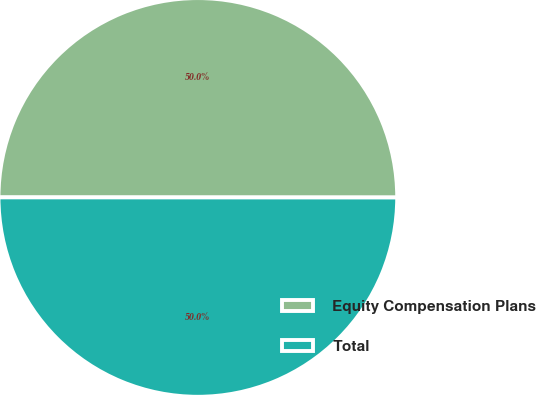Convert chart. <chart><loc_0><loc_0><loc_500><loc_500><pie_chart><fcel>Equity Compensation Plans<fcel>Total<nl><fcel>50.0%<fcel>50.0%<nl></chart> 